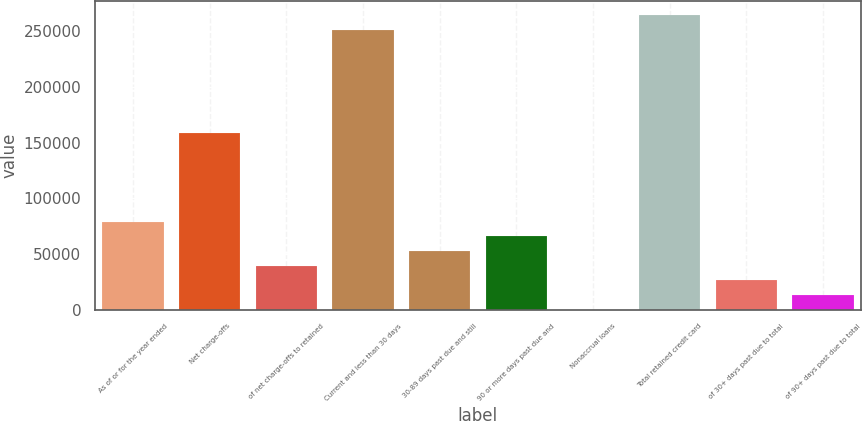<chart> <loc_0><loc_0><loc_500><loc_500><bar_chart><fcel>As of or for the year ended<fcel>Net charge-offs<fcel>of net charge-offs to retained<fcel>Current and less than 30 days<fcel>30-89 days past due and still<fcel>90 or more days past due and<fcel>Nonaccrual loans<fcel>Total retained credit card<fcel>of 30+ days past due to total<fcel>of 90+ days past due to total<nl><fcel>79305.4<fcel>158610<fcel>39653.2<fcel>251132<fcel>52870.6<fcel>66088<fcel>1<fcel>264349<fcel>26435.8<fcel>13218.4<nl></chart> 